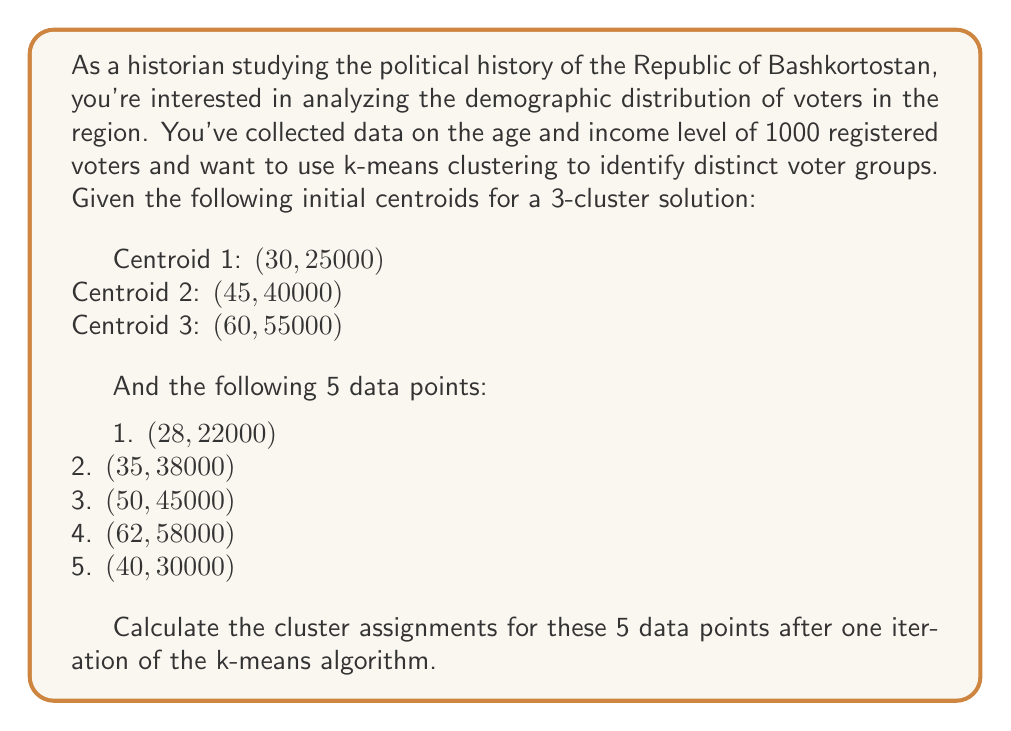Can you answer this question? To solve this problem, we'll follow these steps:

1. Calculate the Euclidean distance between each data point and each centroid.
2. Assign each data point to the cluster with the nearest centroid.

Let's start by calculating the distances:

For each data point $(x_i, y_i)$ and centroid $(c_x, c_y)$, we use the Euclidean distance formula:

$$ d = \sqrt{(x_i - c_x)^2 + (y_i - c_y)^2} $$

1. For point (28, 22000):
   - Distance to Centroid 1: $\sqrt{(28 - 30)^2 + (22000 - 25000)^2} = 3000.07$
   - Distance to Centroid 2: $\sqrt{(28 - 45)^2 + (22000 - 40000)^2} = 18017.11$
   - Distance to Centroid 3: $\sqrt{(28 - 60)^2 + (22000 - 55000)^2} = 33060.55$

2. For point (35, 38000):
   - Distance to Centroid 1: $\sqrt{(35 - 30)^2 + (38000 - 25000)^2} = 13000.19$
   - Distance to Centroid 2: $\sqrt{(35 - 45)^2 + (38000 - 40000)^2} = 10.20$
   - Distance to Centroid 3: $\sqrt{(35 - 60)^2 + (38000 - 55000)^2} = 17088.01$

3. For point (50, 45000):
   - Distance to Centroid 1: $\sqrt{(50 - 30)^2 + (45000 - 25000)^2} = 20615.53$
   - Distance to Centroid 2: $\sqrt{(50 - 45)^2 + (45000 - 40000)^2} = 5000.10$
   - Distance to Centroid 3: $\sqrt{(50 - 60)^2 + (45000 - 55000)^2} = 10049.88$

4. For point (62, 58000):
   - Distance to Centroid 1: $\sqrt{(62 - 30)^2 + (58000 - 25000)^2} = 33241.54$
   - Distance to Centroid 2: $\sqrt{(62 - 45)^2 + (58000 - 40000)^2} = 18110.77$
   - Distance to Centroid 3: $\sqrt{(62 - 60)^2 + (58000 - 55000)^2} = 3000.07$

5. For point (40, 30000):
   - Distance to Centroid 1: $\sqrt{(40 - 30)^2 + (30000 - 25000)^2} = 5009.99$
   - Distance to Centroid 2: $\sqrt{(40 - 45)^2 + (30000 - 40000)^2} = 10000.25$
   - Distance to Centroid 3: $\sqrt{(40 - 60)^2 + (30000 - 55000)^2} = 25019.96$

Now, we assign each point to the cluster with the nearest centroid:

1. Point (28, 22000): Closest to Centroid 1
2. Point (35, 38000): Closest to Centroid 2
3. Point (50, 45000): Closest to Centroid 2
4. Point (62, 58000): Closest to Centroid 3
5. Point (40, 30000): Closest to Centroid 1
Answer: The cluster assignments after one iteration of the k-means algorithm are:

1. (28, 22000): Cluster 1
2. (35, 38000): Cluster 2
3. (50, 45000): Cluster 2
4. (62, 58000): Cluster 3
5. (40, 30000): Cluster 1 